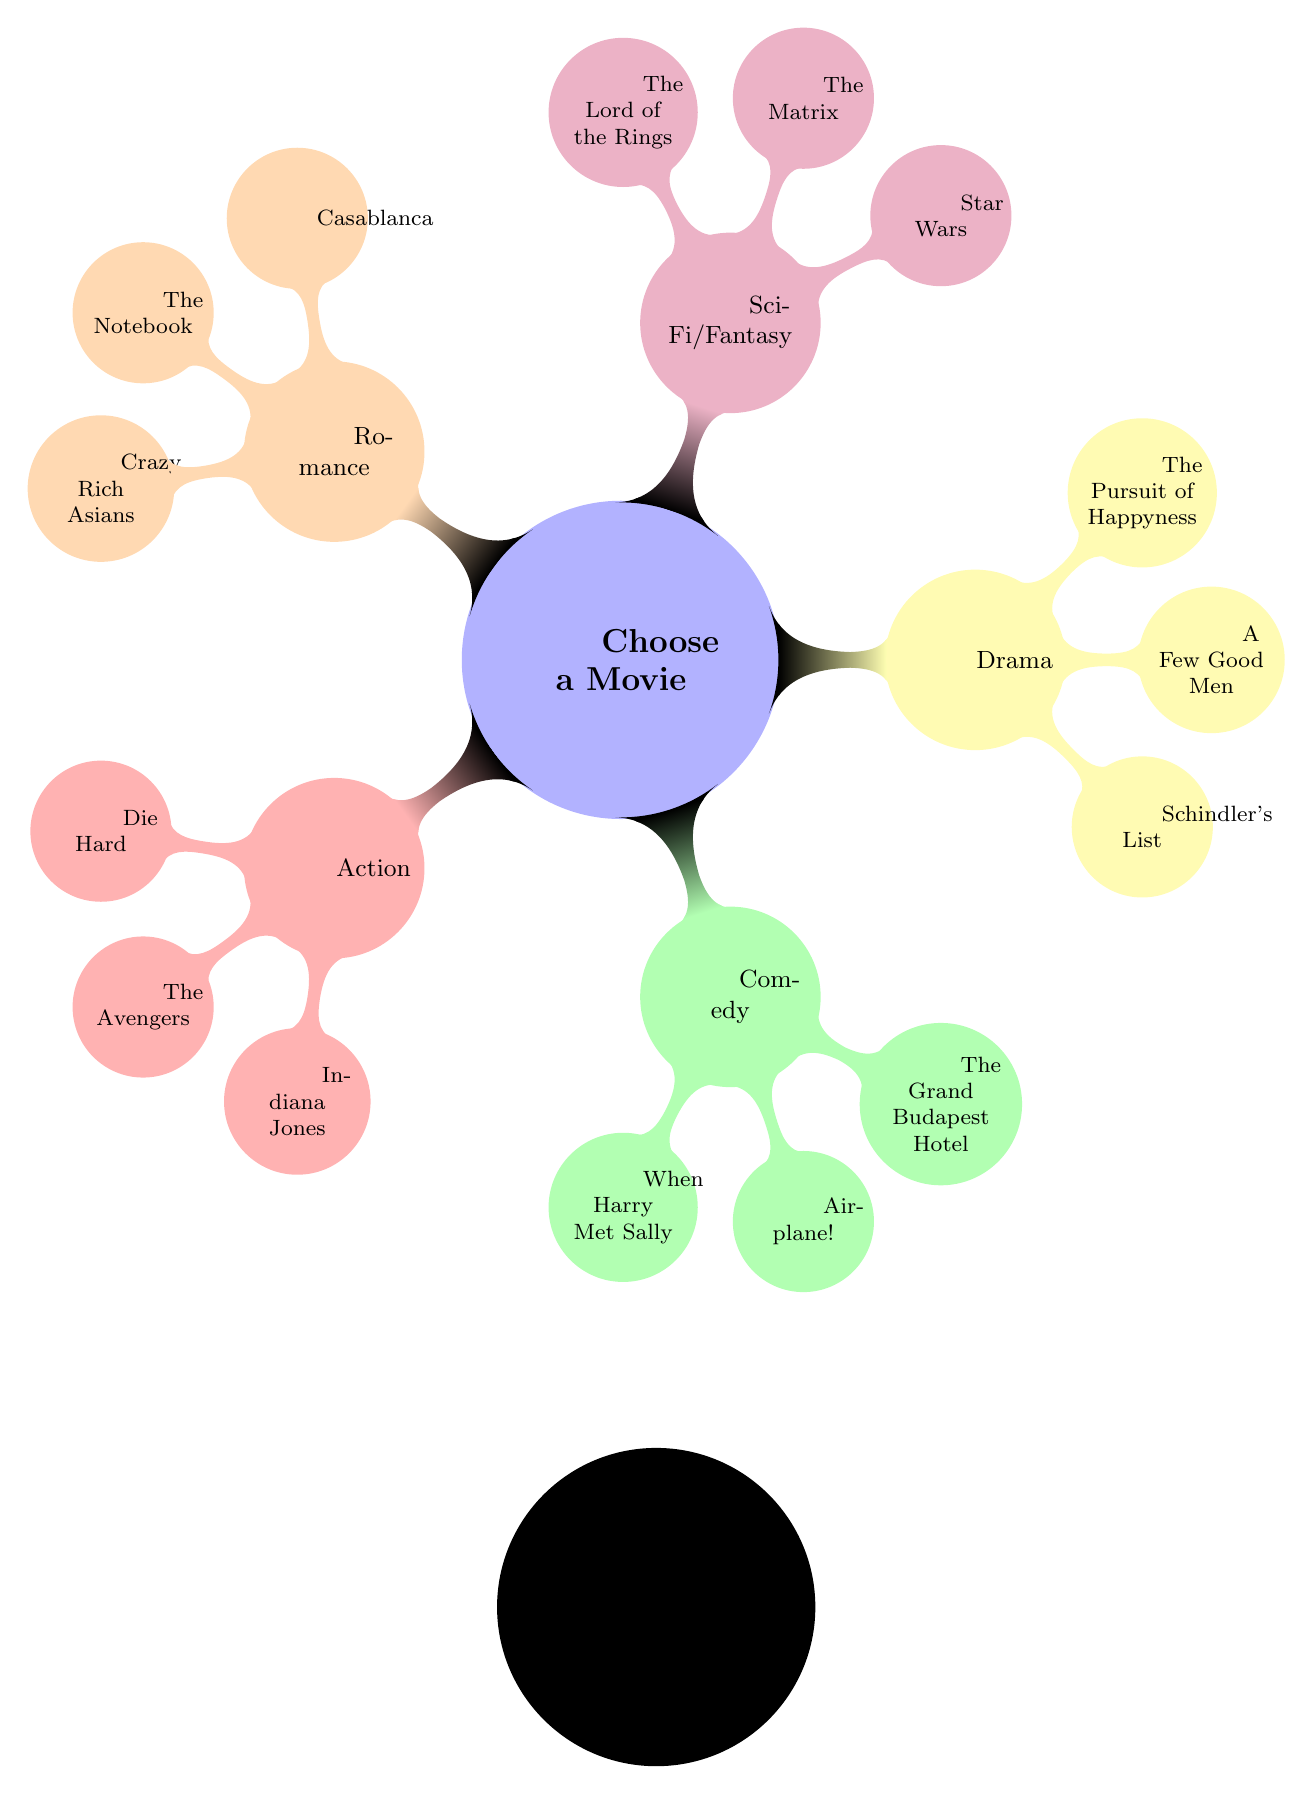What's the first step in the flow chart? The first step in the flow chart is "Choose the genre you are in the mood for," which is the starting point of the process.
Answer: Choose the genre you are in the mood for How many genre options are listed in the flow chart? The flow chart lists five genre options: Action, Comedy, Drama, Sci-Fi/Fantasy, and Romance. Therefore, the total number of genre options is five.
Answer: 5 Which action movie is listed under the Classic sub-genre? The flow chart specifies "Die Hard" as the action movie listed under the Classic sub-genre.
Answer: Die Hard What is the relationship between Comedy and its sub-genres? The relationship is that Comedy is one of the main genres, and it has three sub-genres: Romantic Comedy, Slapstick, and Satire, each leading to a specific movie recommendation.
Answer: Comedy has three sub-genres If choosing Sci-Fi/Fantasy, which movie is recommended for Alternate Reality? The recommended movie for Alternate Reality under the Sci-Fi/Fantasy genre is "The Matrix."
Answer: The Matrix Which genre has "Crazy Rich Asians" as a recommendation? "Crazy Rich Asians" is a recommendation under the Romance genre.
Answer: Romance If someone is in the mood for a heartwarming story, which genre should they choose? A heartwarming story fits best in the Romance genre, as indicated in the flow chart.
Answer: Romance What are the three options available under the Drama genre? The Drama genre has three options listed: Historical, Legal, and Family, each leading to its own movie recommendation.
Answer: Historical, Legal, Family How can you identify the end of the process in the flow chart? The end of the process is marked by the node "Enjoy your movie night!" which signifies the conclusion after selecting a movie.
Answer: Enjoy your movie night! 